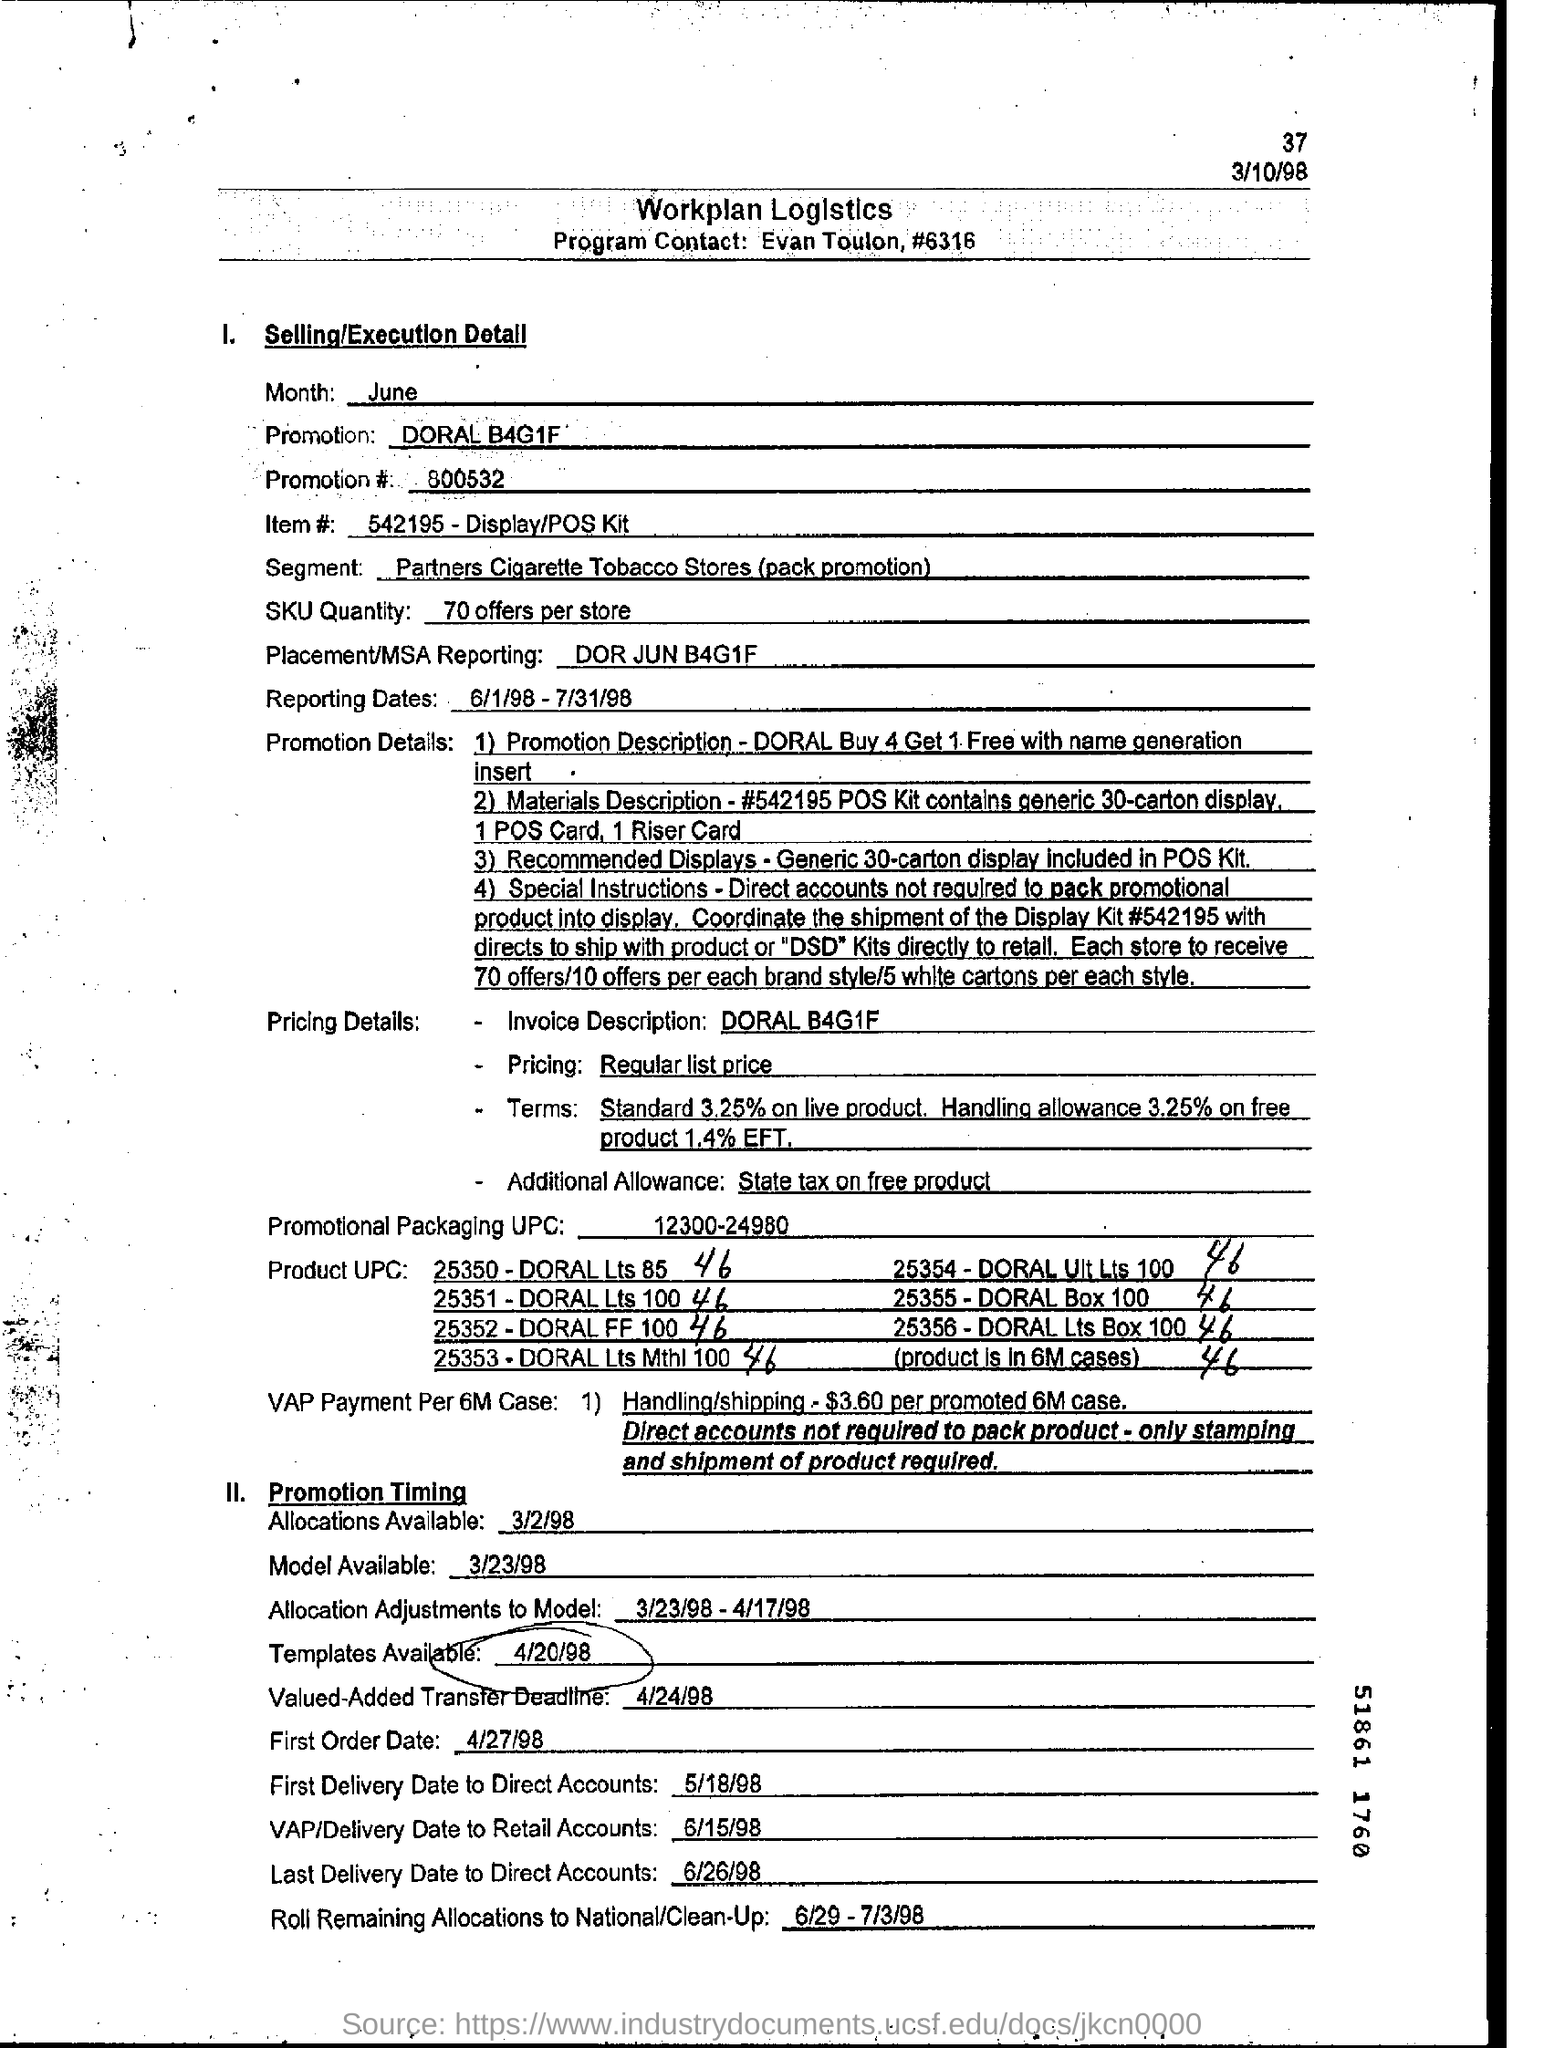Who is the Program Contact?
Keep it short and to the point. Evan toulon. What is the Promotion?
Your answer should be very brief. DORAL B4G1F. What is the Promotion # ?
Ensure brevity in your answer.  800532. What are the Reporting dates?
Give a very brief answer. 6/1/98 -7/31/98. What is the Invoice Desciption?
Provide a succinct answer. DORAL B4G1F. What is the First Order Date?
Make the answer very short. 4/27/98. What is the Last Delivery Date to Direct Accounts?
Provide a succinct answer. 6/26/98. 